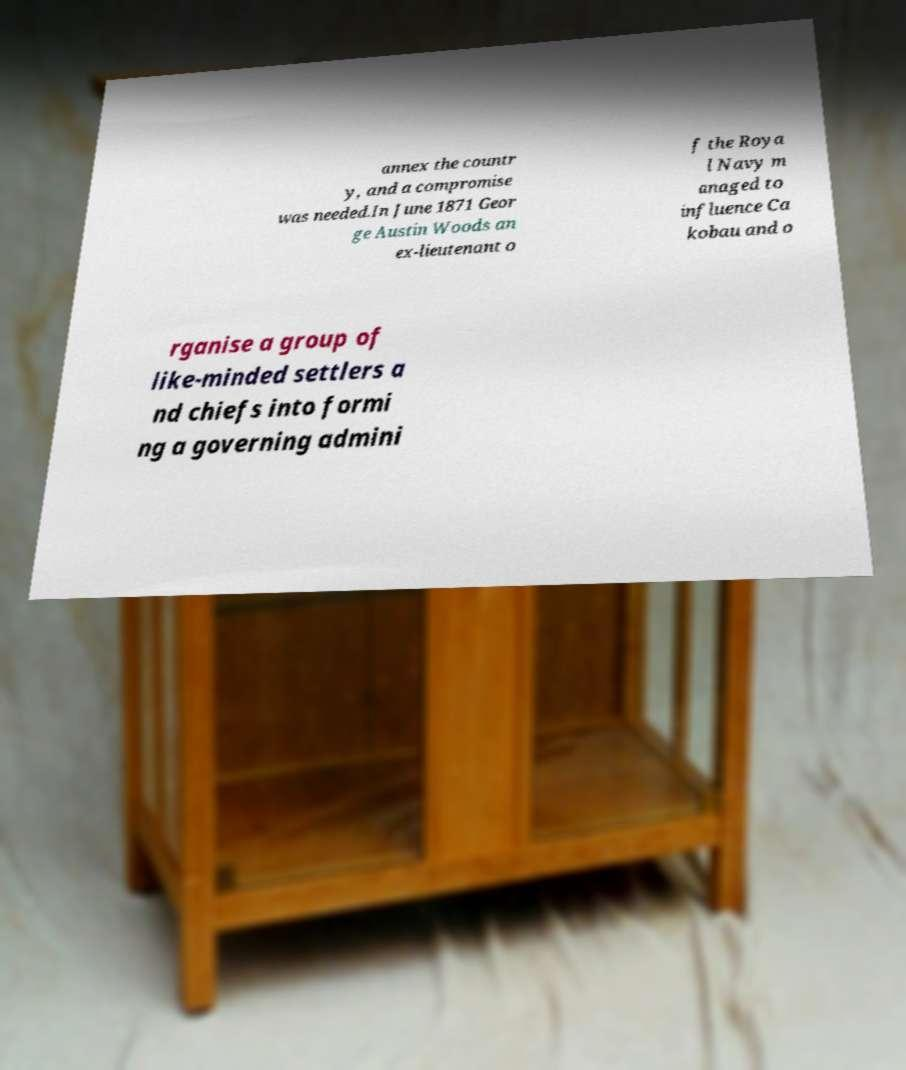I need the written content from this picture converted into text. Can you do that? annex the countr y, and a compromise was needed.In June 1871 Geor ge Austin Woods an ex-lieutenant o f the Roya l Navy m anaged to influence Ca kobau and o rganise a group of like-minded settlers a nd chiefs into formi ng a governing admini 